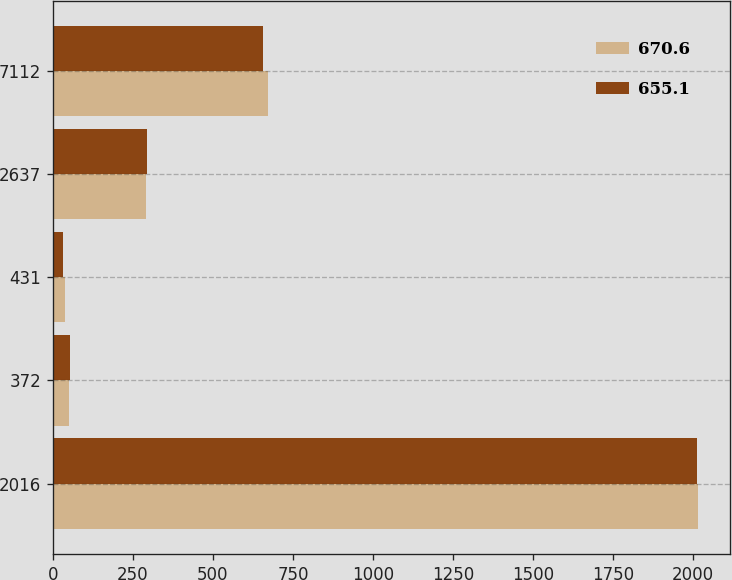Convert chart. <chart><loc_0><loc_0><loc_500><loc_500><stacked_bar_chart><ecel><fcel>2016<fcel>372<fcel>431<fcel>2637<fcel>7112<nl><fcel>670.6<fcel>2015<fcel>48.4<fcel>36.4<fcel>291.9<fcel>670.6<nl><fcel>655.1<fcel>2014<fcel>53.2<fcel>31.1<fcel>294.1<fcel>655.1<nl></chart> 